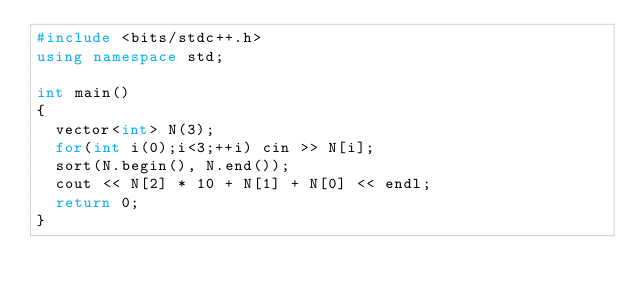<code> <loc_0><loc_0><loc_500><loc_500><_C++_>#include <bits/stdc++.h>
using namespace std;

int main()
{
	vector<int> N(3);
	for(int i(0);i<3;++i) cin >> N[i];
	sort(N.begin(), N.end());
	cout << N[2] * 10 + N[1] + N[0] << endl;
	return 0;
}</code> 